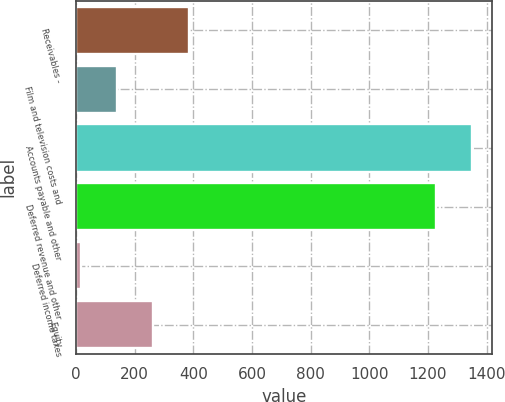<chart> <loc_0><loc_0><loc_500><loc_500><bar_chart><fcel>Receivables -<fcel>Film and television costs and<fcel>Accounts payable and other<fcel>Deferred revenue and other<fcel>Deferred income taxes<fcel>Equity<nl><fcel>386.3<fcel>140.1<fcel>1351.1<fcel>1228<fcel>17<fcel>263.2<nl></chart> 